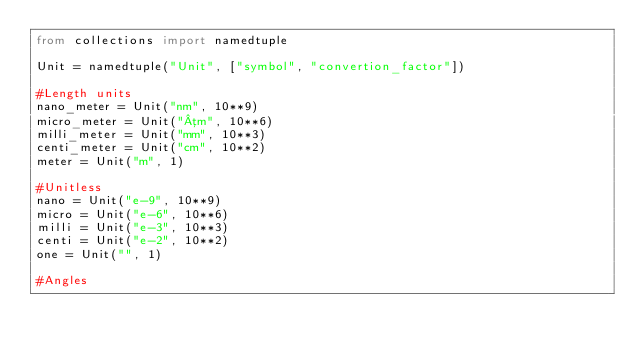Convert code to text. <code><loc_0><loc_0><loc_500><loc_500><_Python_>from collections import namedtuple

Unit = namedtuple("Unit", ["symbol", "convertion_factor"])

#Length units
nano_meter = Unit("nm", 10**9)
micro_meter = Unit("µm", 10**6)
milli_meter = Unit("mm", 10**3)
centi_meter = Unit("cm", 10**2)
meter = Unit("m", 1)

#Unitless 
nano = Unit("e-9", 10**9)
micro = Unit("e-6", 10**6)
milli = Unit("e-3", 10**3)
centi = Unit("e-2", 10**2)
one = Unit("", 1)

#Angles</code> 